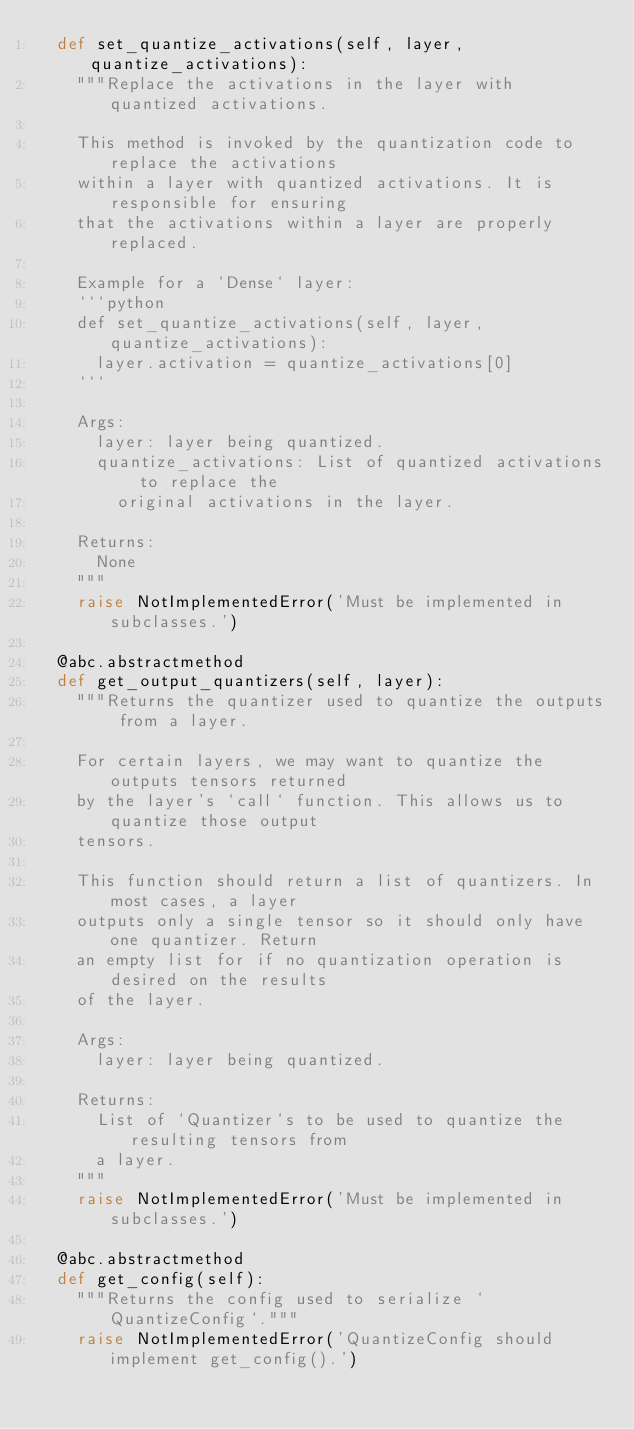Convert code to text. <code><loc_0><loc_0><loc_500><loc_500><_Python_>  def set_quantize_activations(self, layer, quantize_activations):
    """Replace the activations in the layer with quantized activations.

    This method is invoked by the quantization code to replace the activations
    within a layer with quantized activations. It is responsible for ensuring
    that the activations within a layer are properly replaced.

    Example for a `Dense` layer:
    ```python
    def set_quantize_activations(self, layer, quantize_activations):
      layer.activation = quantize_activations[0]
    ```

    Args:
      layer: layer being quantized.
      quantize_activations: List of quantized activations to replace the
        original activations in the layer.

    Returns:
      None
    """
    raise NotImplementedError('Must be implemented in subclasses.')

  @abc.abstractmethod
  def get_output_quantizers(self, layer):
    """Returns the quantizer used to quantize the outputs from a layer.

    For certain layers, we may want to quantize the outputs tensors returned
    by the layer's `call` function. This allows us to quantize those output
    tensors.

    This function should return a list of quantizers. In most cases, a layer
    outputs only a single tensor so it should only have one quantizer. Return
    an empty list for if no quantization operation is desired on the results
    of the layer.

    Args:
      layer: layer being quantized.

    Returns:
      List of `Quantizer`s to be used to quantize the resulting tensors from
      a layer.
    """
    raise NotImplementedError('Must be implemented in subclasses.')

  @abc.abstractmethod
  def get_config(self):
    """Returns the config used to serialize `QuantizeConfig`."""
    raise NotImplementedError('QuantizeConfig should implement get_config().')
</code> 